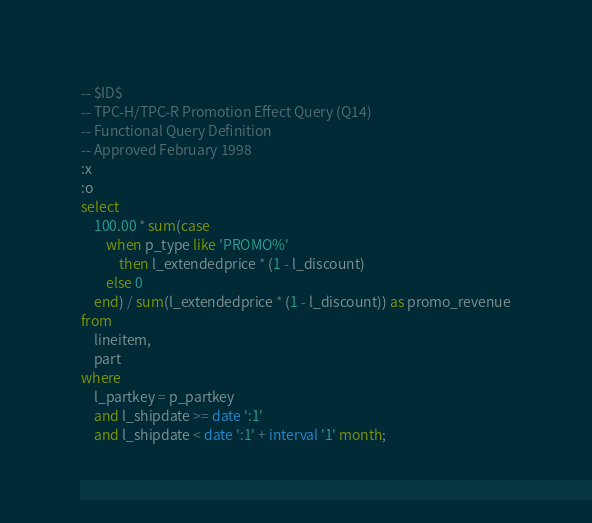<code> <loc_0><loc_0><loc_500><loc_500><_SQL_>-- $ID$
-- TPC-H/TPC-R Promotion Effect Query (Q14)
-- Functional Query Definition
-- Approved February 1998
:x
:o
select
	100.00 * sum(case
		when p_type like 'PROMO%'
			then l_extendedprice * (1 - l_discount)
		else 0
	end) / sum(l_extendedprice * (1 - l_discount)) as promo_revenue
from
	lineitem,
	part
where
	l_partkey = p_partkey
	and l_shipdate >= date ':1'
	and l_shipdate < date ':1' + interval '1' month;
</code> 